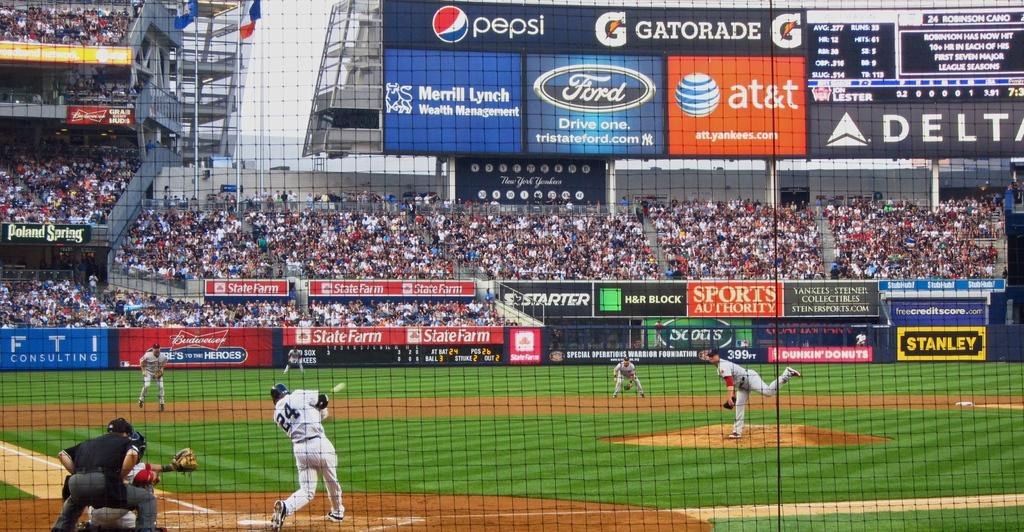<image>
Render a clear and concise summary of the photo. A batter swings at a pitch in a stadium in front of billboards showing Pepsi and Gatorade ads (among others) 